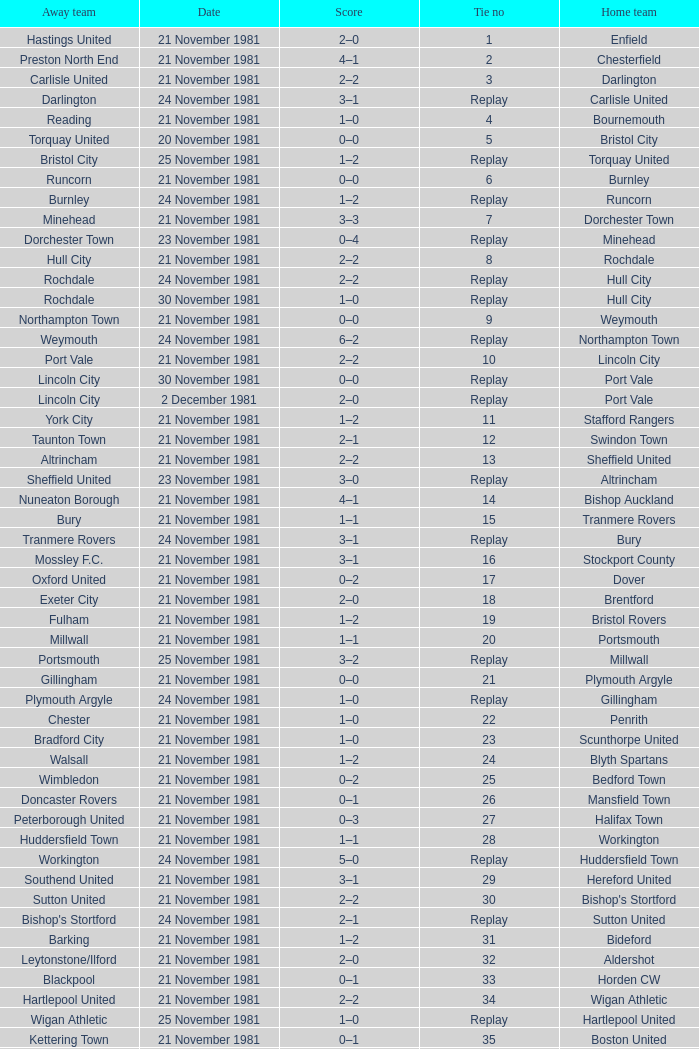Minehead has what tie number? Replay. 